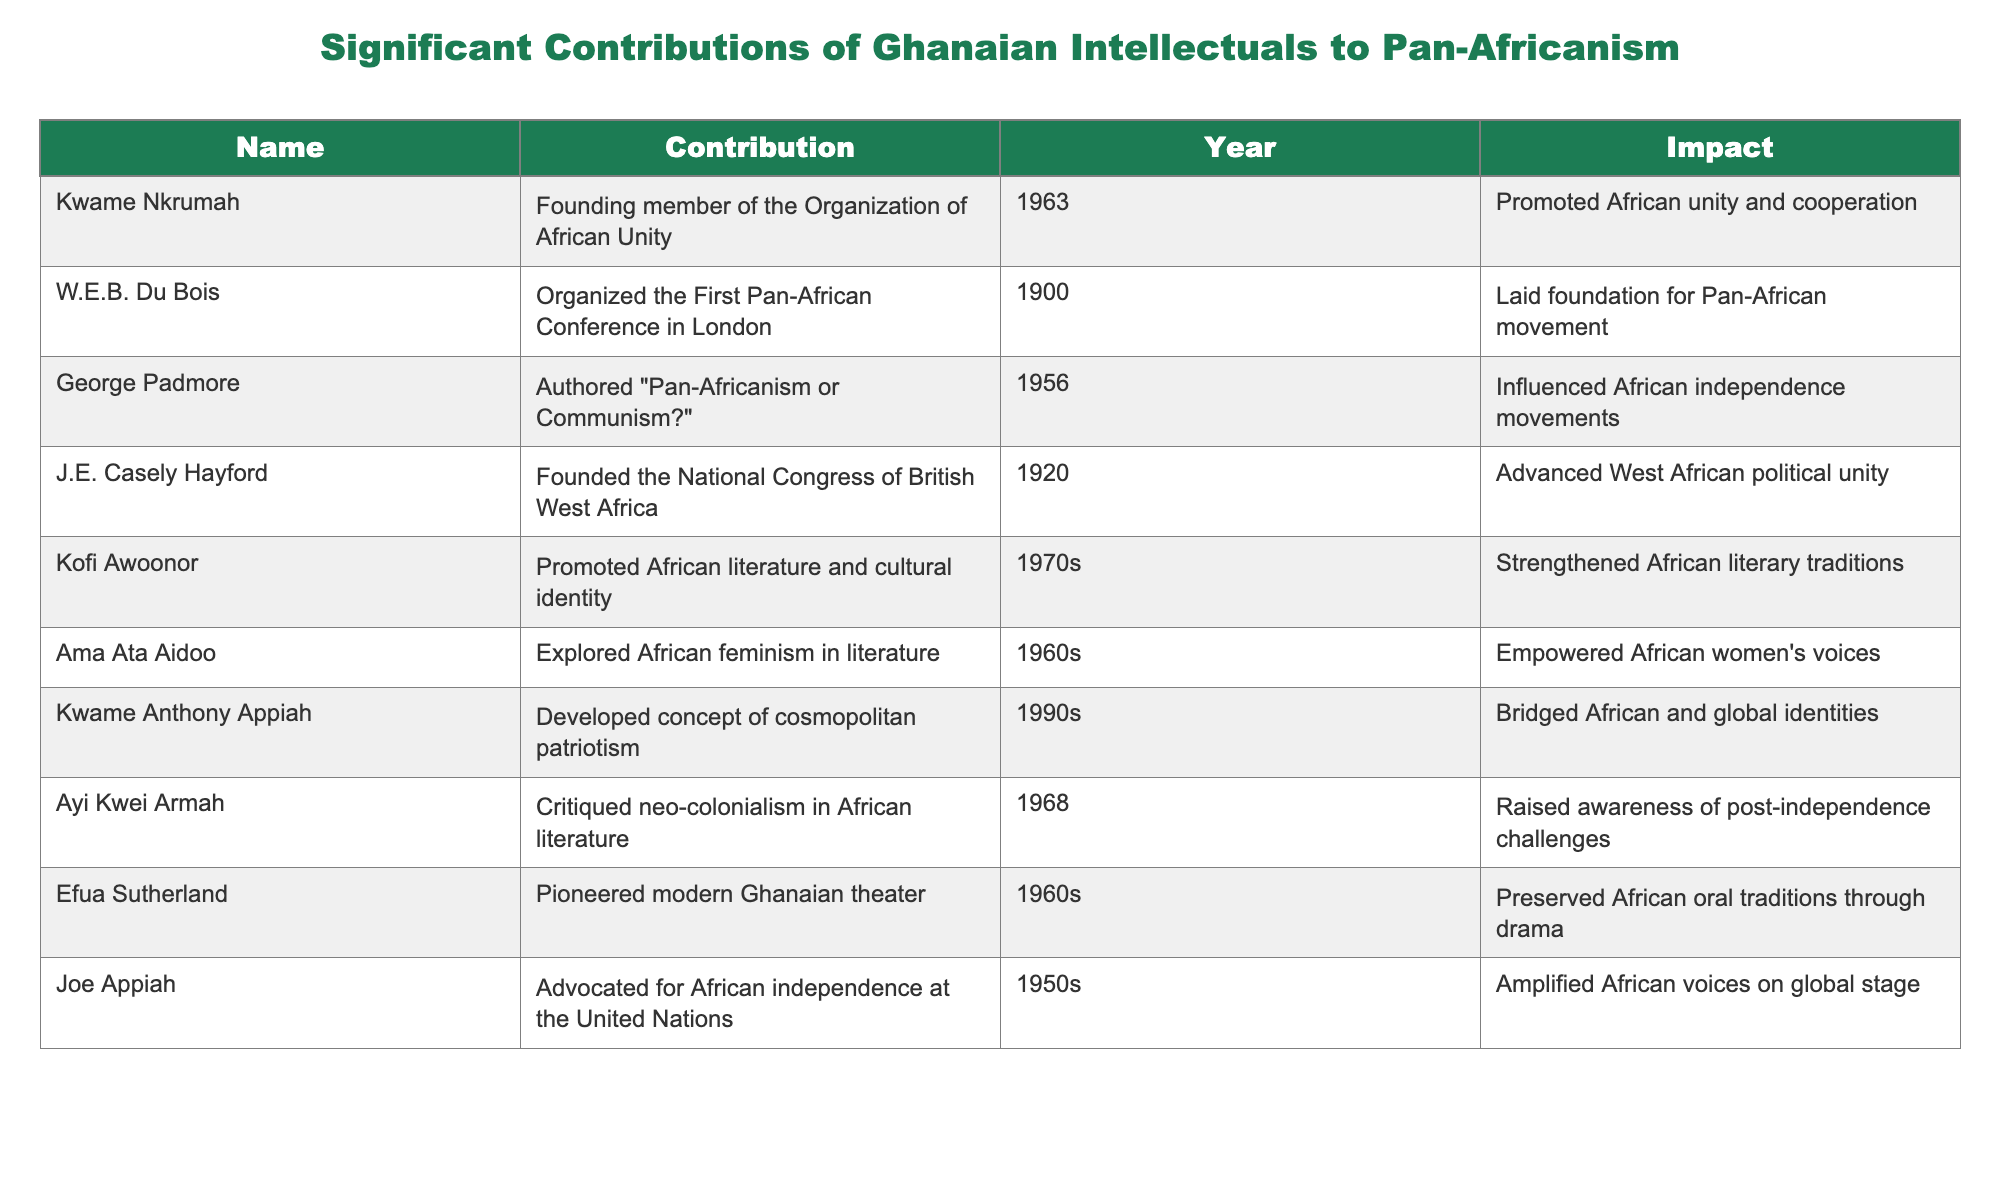What was Kwame Nkrumah's contribution to Pan-Africanism? According to the table, Kwame Nkrumah was a founding member of the Organization of African Unity.
Answer: Founding member of the Organization of African Unity Who organized the First Pan-African Conference and in what year? The table indicates that W.E.B. Du Bois organized the First Pan-African Conference in London in 1900.
Answer: W.E.B. Du Bois, 1900 Which intellectual authored "Pan-Africanism or Communism?" and in what year? The table shows that George Padmore authored "Pan-Africanism or Communism?" in 1956.
Answer: George Padmore, 1956 What was the impact of J.E. Casely Hayford's work? The table states that J.E. Casely Hayford advanced West African political unity through his efforts.
Answer: Advanced West African political unity How many individuals are listed as contributing to Pan-Africanism in the table? By counting the entries, there are 10 individuals listed in the table.
Answer: 10 Which two contributors from the table focused on literature and cultural identity? The table identifies Kofi Awoonor and Ama Ata Aidoo as contributors who focused on literature and cultural identity.
Answer: Kofi Awoonor and Ama Ata Aidoo What impact did Kofi Awoonor have on African traditions? Kofi Awoonor's work in the 1970s is noted for strengthening African literary traditions, according to the table.
Answer: Strengthened African literary traditions Did Joe Appiah advocate for African independence? Yes, the table confirms that Joe Appiah advocated for African independence at the United Nations in the 1950s.
Answer: Yes Which intellectual made significant contributions in the 1960s? The table lists several intellectuals who contributed in the 1960s, including Ama Ata Aidoo, Ayi Kwei Armah, and Efua Sutherland.
Answer: Ama Ata Aidoo, Ayi Kwei Armah, Efua Sutherland What is the year range of the contributions listed in the table? The earliest contribution is from 1900 by W.E.B. Du Bois and the latest is from the 1990s by Kwame Anthony Appiah, making the range from 1900 to 1990s.
Answer: 1900 to 1990s How did Kwame Anthony Appiah's work influence identities? Appiah developed the concept of cosmopolitan patriotism, which bridged African and global identities according to the table.
Answer: Bridged African and global identities Which intellectual focused on African feminism? The table indicates that Ama Ata Aidoo explored African feminism in literature during the 1960s.
Answer: Ama Ata Aidoo What do the contributions of the intellectuals in the table indicate about Ghana's role in Pan-Africanism? The contributions highlight that Ghanaian intellectuals played a vital role in promoting African unity, independence, and cultural identity, demonstrating Ghana's leadership in Pan-Africanism.
Answer: Highlighted Ghana's vital role in Pan-Africanism 